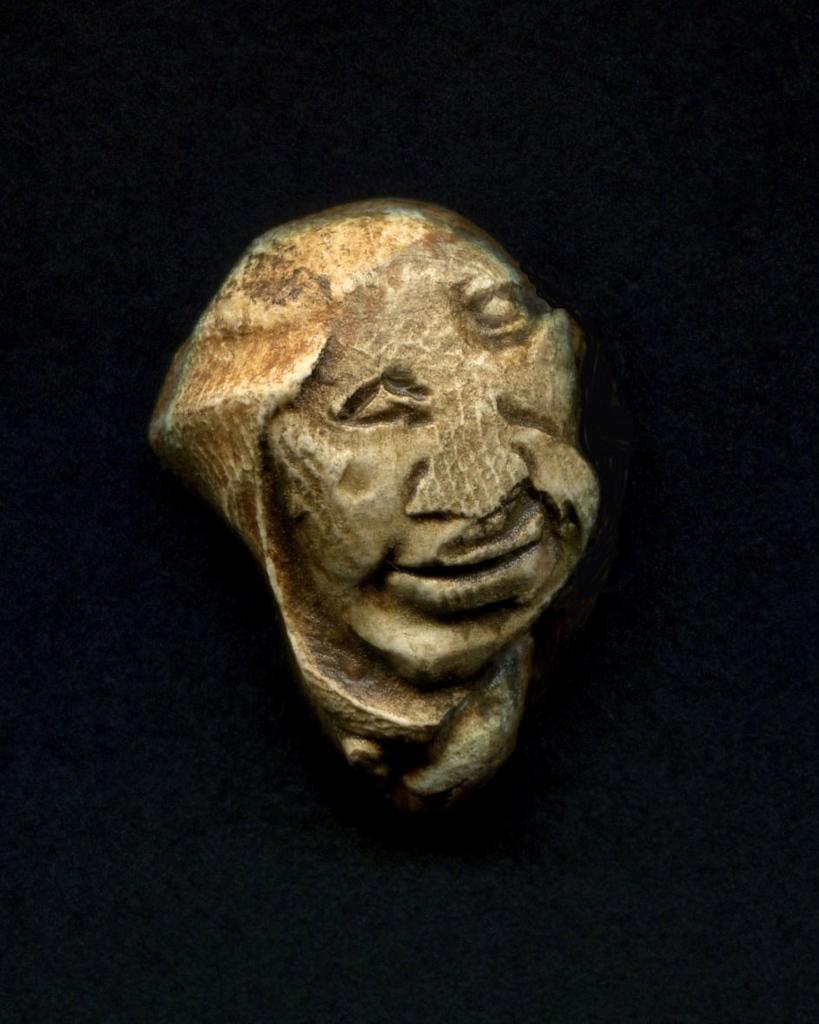How would you summarize this image in a sentence or two? In the center of the image we can see the sculpture. 